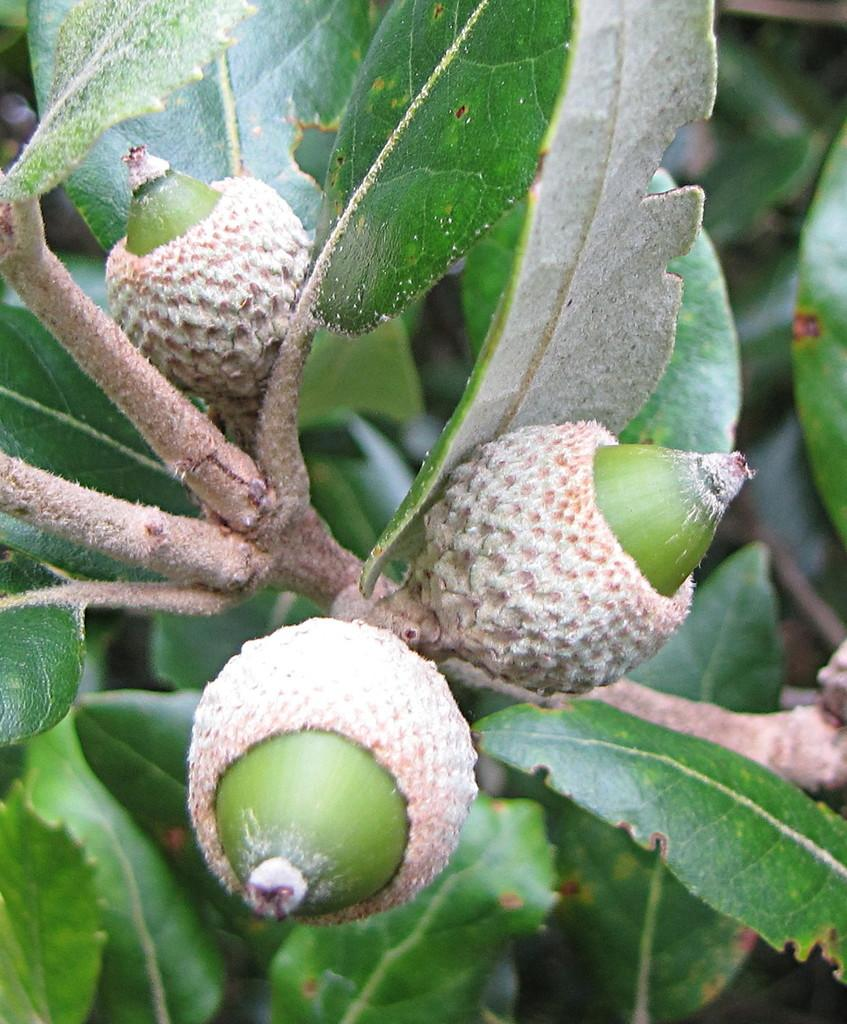What type of living organisms can be seen on the plant in the image? There are fruits on the plant in the image. Can you describe the fruits on the plant? Unfortunately, the specific type of fruits cannot be determined from the image alone. What is the natural setting of the image? The image features a plant with fruits, which suggests a natural setting. What color is the cloud in the image? There is no cloud present in the image; it features a plant with fruits. How many oranges are hanging from the plant in the image? The specific type of fruits cannot be determined from the image alone, so it is impossible to say if they are oranges or not. 